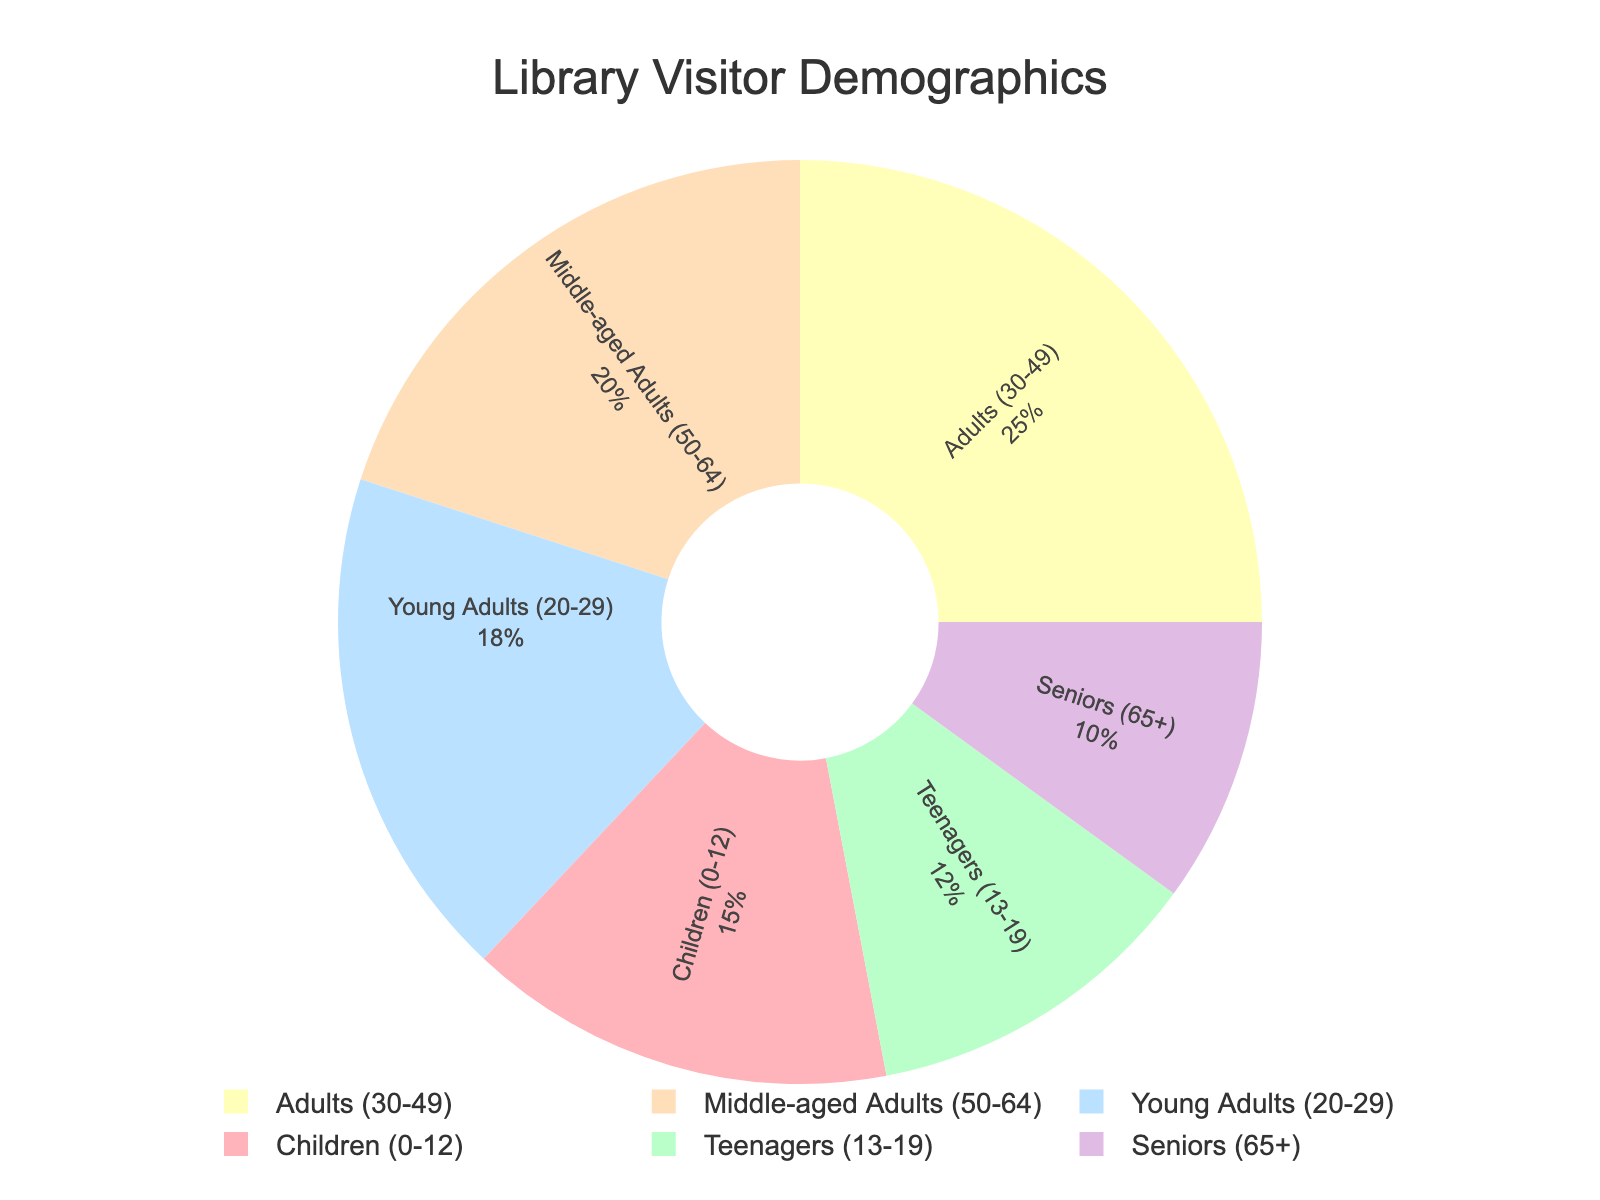What percentage of the library visitors are Seniors? The pie chart shows that Seniors (65+) account for 10% of library visitors.
Answer: 10% Which age group has the highest percentage of library visitors? By looking at the pie chart, we see that Adults (30-49) have the highest percentage at 25%.
Answer: Adults (30-49) How does the percentage of Children compare to that of Middle-aged Adults? The pie chart shows that Children (0-12) make up 15% of the visitors, whereas Middle-aged Adults (50-64) make up 20%. Thus, Middle-aged Adults have a greater percentage than Children.
Answer: Middle-aged Adults have a greater percentage What is the combined percentage of Teenagers and Young Adults? Teenagers (13-19) account for 12% and Young Adults (20-29) account for 18%. Adding these together, 12% + 18% = 30%.
Answer: 30% Which age group has the lowest percentage of library visitors, and what is that percentage? By observing the pie chart, we can see that Seniors (65+) have the lowest percentage of library visitors at 10%.
Answer: Seniors (10%) Is the combined percentage of Children and Seniors greater than the percentage of Adults? Children account for 15% and Seniors for 10%, combined they make 15% + 10% = 25%. The percentage of Adults (30-49) is also 25%. Therefore, they are equal.
Answer: No, it is equal What's the difference between the percentages of Middle-aged Adults and Teenagers? Middle-aged Adults (50-64) are 20% and Teenagers (13-19) are 12%. The difference is 20% - 12% = 8%.
Answer: 8% If you were to combine the percentage of Children and Teenagers, would it exceed the percentage of Young Adults? Children are 15% and Teenagers are 12%. Combined, this is 15% + 12% = 27%. Young Adults are 18%, so 27% is greater than 18%.
Answer: Yes What percentage of visitors fall into the age groups spanning from 20 to 64 years? This includes Young Adults (20-29) at 18%, Adults (30-49) at 25%, and Middle-aged Adults (50-64) at 20%. Adding these together, 18% + 25% + 20% = 63%.
Answer: 63% How much greater is the percentage of Adults compared to the percentage of Seniors? Adults (30-49) account for 25% of the visitors, and Seniors (65+) account for 10%. The difference is 25% - 10% = 15%.
Answer: 15% 